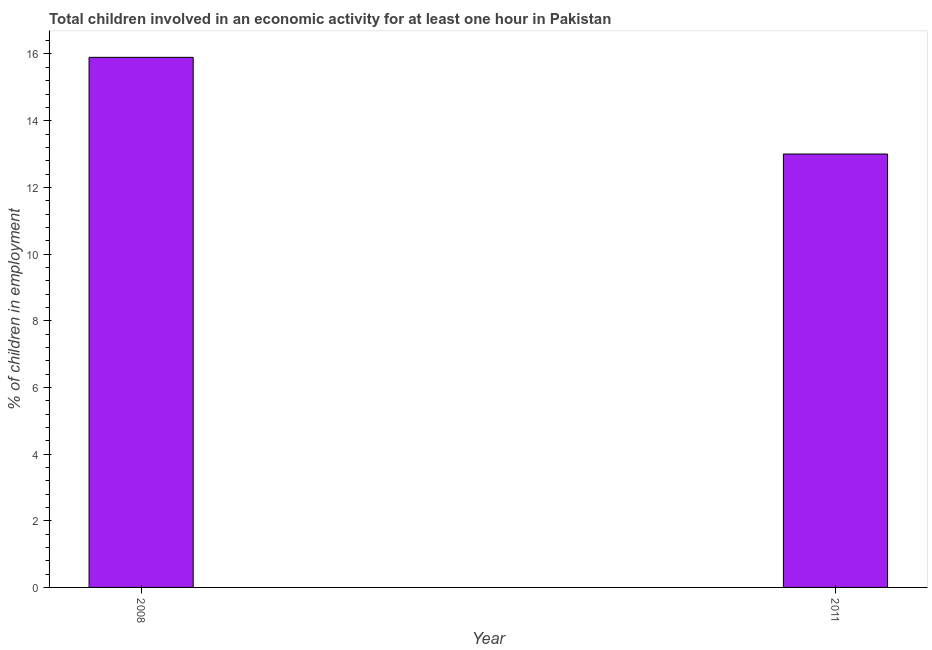What is the title of the graph?
Provide a succinct answer. Total children involved in an economic activity for at least one hour in Pakistan. What is the label or title of the X-axis?
Keep it short and to the point. Year. What is the label or title of the Y-axis?
Your answer should be very brief. % of children in employment. In which year was the percentage of children in employment maximum?
Give a very brief answer. 2008. In which year was the percentage of children in employment minimum?
Provide a succinct answer. 2011. What is the sum of the percentage of children in employment?
Your answer should be very brief. 28.9. What is the difference between the percentage of children in employment in 2008 and 2011?
Make the answer very short. 2.9. What is the average percentage of children in employment per year?
Your response must be concise. 14.45. What is the median percentage of children in employment?
Your answer should be very brief. 14.45. In how many years, is the percentage of children in employment greater than 9.2 %?
Your answer should be compact. 2. What is the ratio of the percentage of children in employment in 2008 to that in 2011?
Offer a very short reply. 1.22. How many bars are there?
Give a very brief answer. 2. How many years are there in the graph?
Ensure brevity in your answer.  2. Are the values on the major ticks of Y-axis written in scientific E-notation?
Your response must be concise. No. What is the % of children in employment in 2011?
Offer a very short reply. 13. What is the difference between the % of children in employment in 2008 and 2011?
Make the answer very short. 2.9. What is the ratio of the % of children in employment in 2008 to that in 2011?
Your answer should be compact. 1.22. 